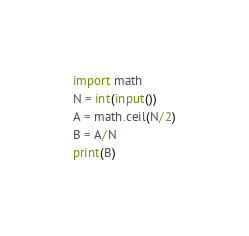Convert code to text. <code><loc_0><loc_0><loc_500><loc_500><_Python_>import math
N = int(input())
A = math.ceil(N/2)
B = A/N
print(B)</code> 